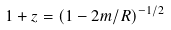<formula> <loc_0><loc_0><loc_500><loc_500>1 + z = ( 1 - 2 m / R ) ^ { - 1 / 2 }</formula> 